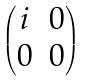<formula> <loc_0><loc_0><loc_500><loc_500>\begin{pmatrix} i & 0 \\ 0 & 0 \end{pmatrix}</formula> 